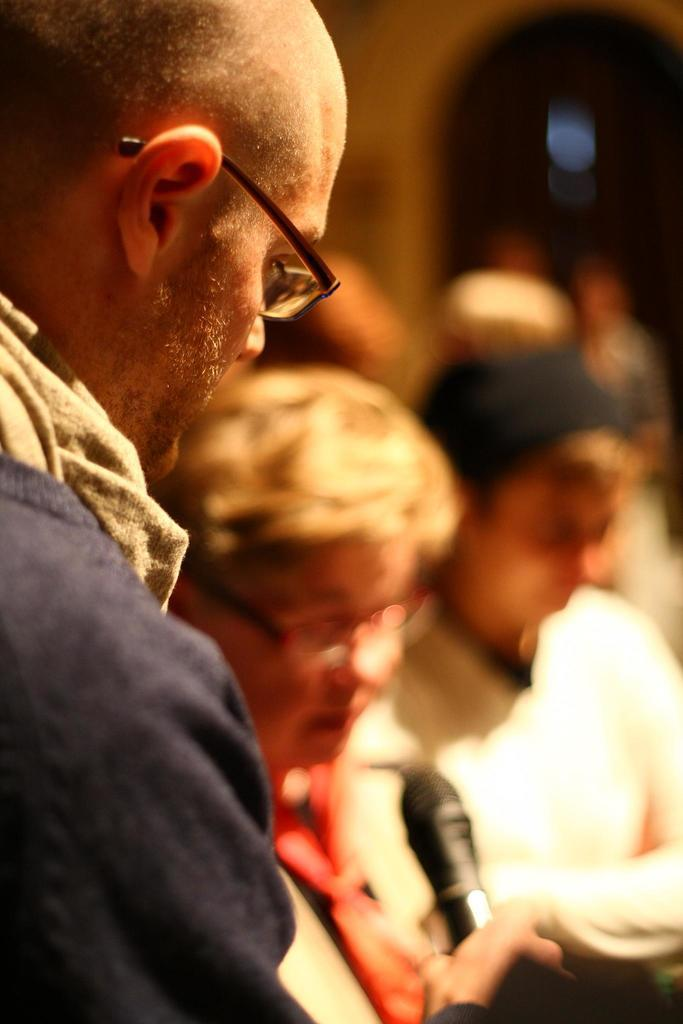How many people are in the image? There is a group of people in the image, but the exact number is not specified. What is one person in the group doing? There is a person holding a mic in the image. What type of riddle can be heard being solved by the robin in the image? There is no robin or riddle present in the image; it features a group of people and a person holding a mic. 